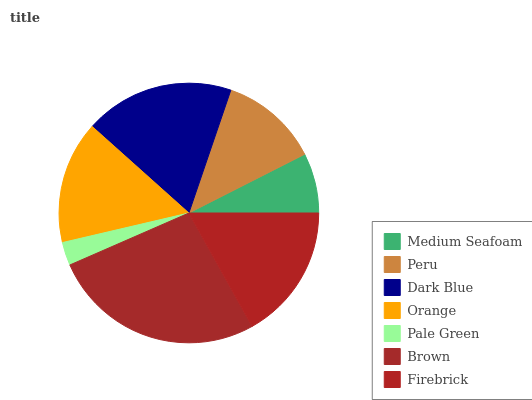Is Pale Green the minimum?
Answer yes or no. Yes. Is Brown the maximum?
Answer yes or no. Yes. Is Peru the minimum?
Answer yes or no. No. Is Peru the maximum?
Answer yes or no. No. Is Peru greater than Medium Seafoam?
Answer yes or no. Yes. Is Medium Seafoam less than Peru?
Answer yes or no. Yes. Is Medium Seafoam greater than Peru?
Answer yes or no. No. Is Peru less than Medium Seafoam?
Answer yes or no. No. Is Orange the high median?
Answer yes or no. Yes. Is Orange the low median?
Answer yes or no. Yes. Is Firebrick the high median?
Answer yes or no. No. Is Dark Blue the low median?
Answer yes or no. No. 